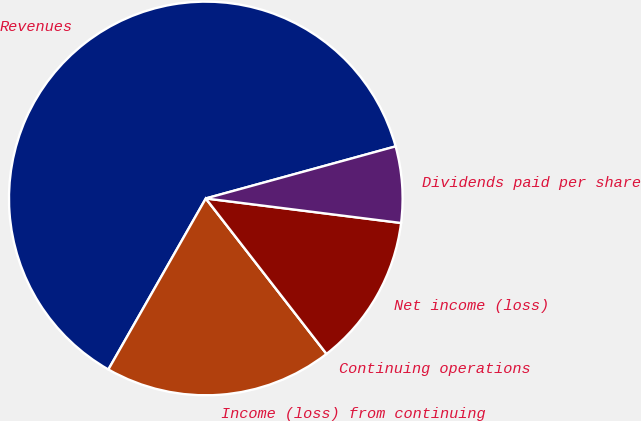Convert chart. <chart><loc_0><loc_0><loc_500><loc_500><pie_chart><fcel>Revenues<fcel>Income (loss) from continuing<fcel>Continuing operations<fcel>Net income (loss)<fcel>Dividends paid per share<nl><fcel>62.49%<fcel>18.75%<fcel>0.0%<fcel>12.5%<fcel>6.25%<nl></chart> 